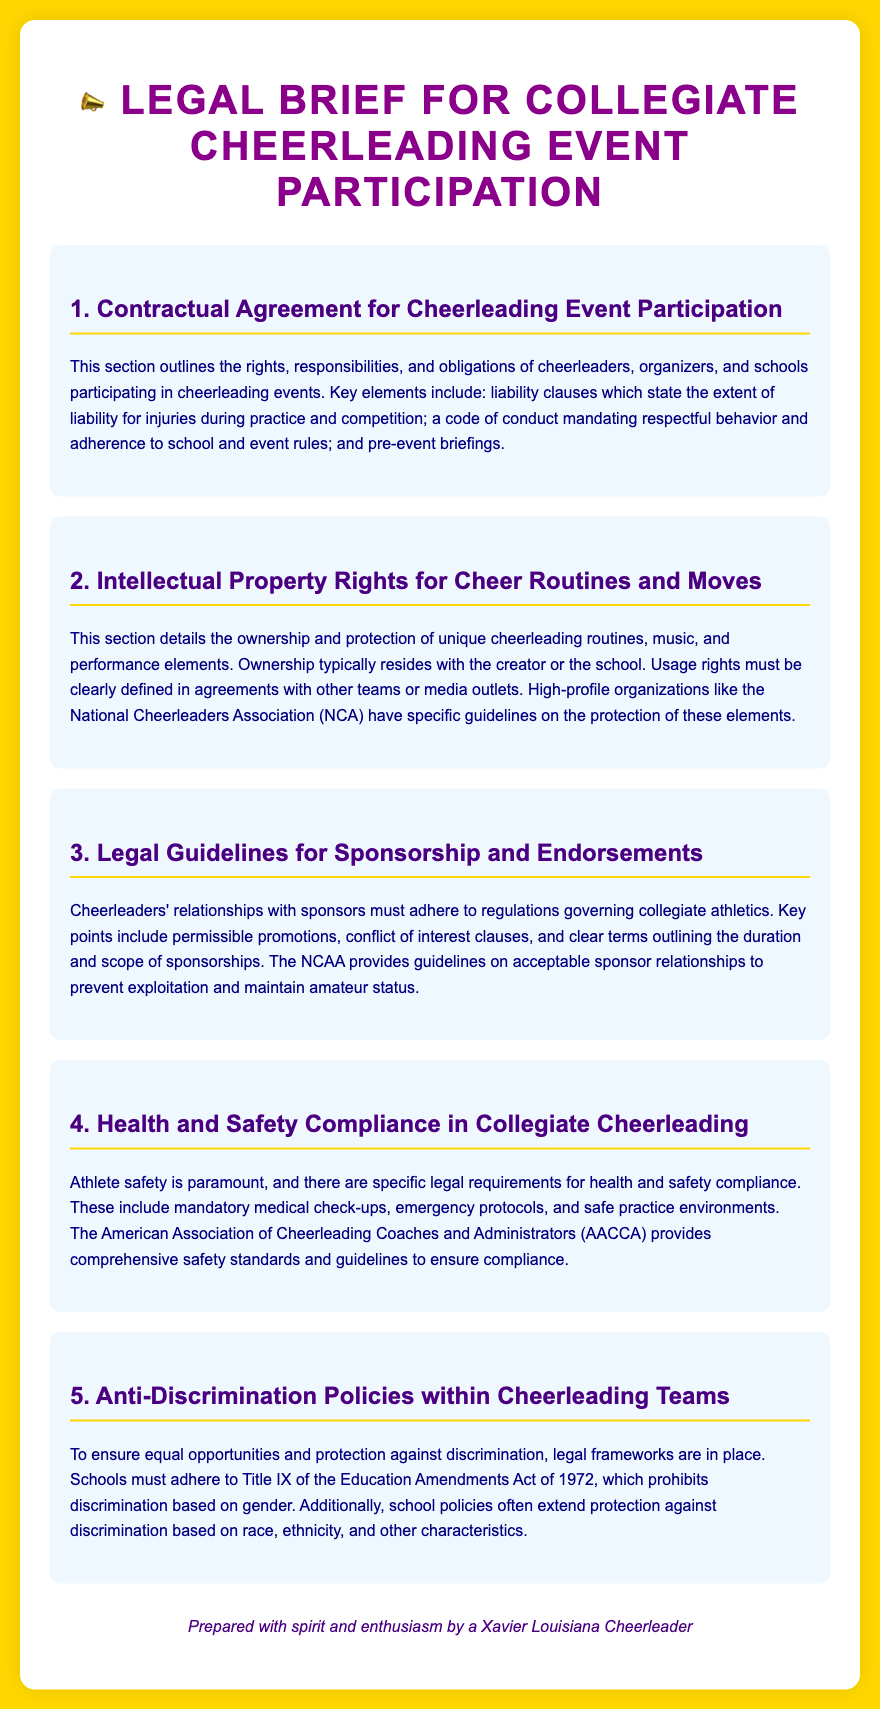What is the main focus of the first section? The first section outlines the rights, responsibilities, and obligations of cheerleaders, organizers, and schools participating in cheerleading events.
Answer: rights, responsibilities, and obligations Who typically holds ownership of cheer routines? The document states that ownership typically resides with the creator or the school.
Answer: creator or the school What legal requirement is emphasized for athlete safety? Mandatory medical check-ups are mentioned as a legal requirement for athlete safety.
Answer: mandatory medical check-ups Which organization provides safety standards for cheerleading? The American Association of Cheerleading Coaches and Administrators (AACCA) provides comprehensive safety standards and guidelines.
Answer: AACCA What does Title IX prohibit? Title IX prohibits discrimination based on gender.
Answer: gender What is one of the key components in the guidelines for sponsorship? The guidelines include conflict of interest clauses as one of the key components.
Answer: conflict of interest clauses What color is used for the section headings? The section headings are colored purple, specifically #4B0082.
Answer: purple What must schools adhere to according to anti-discrimination policies? Schools must adhere to Title IX of the Education Amendments Act of 1972.
Answer: Title IX 